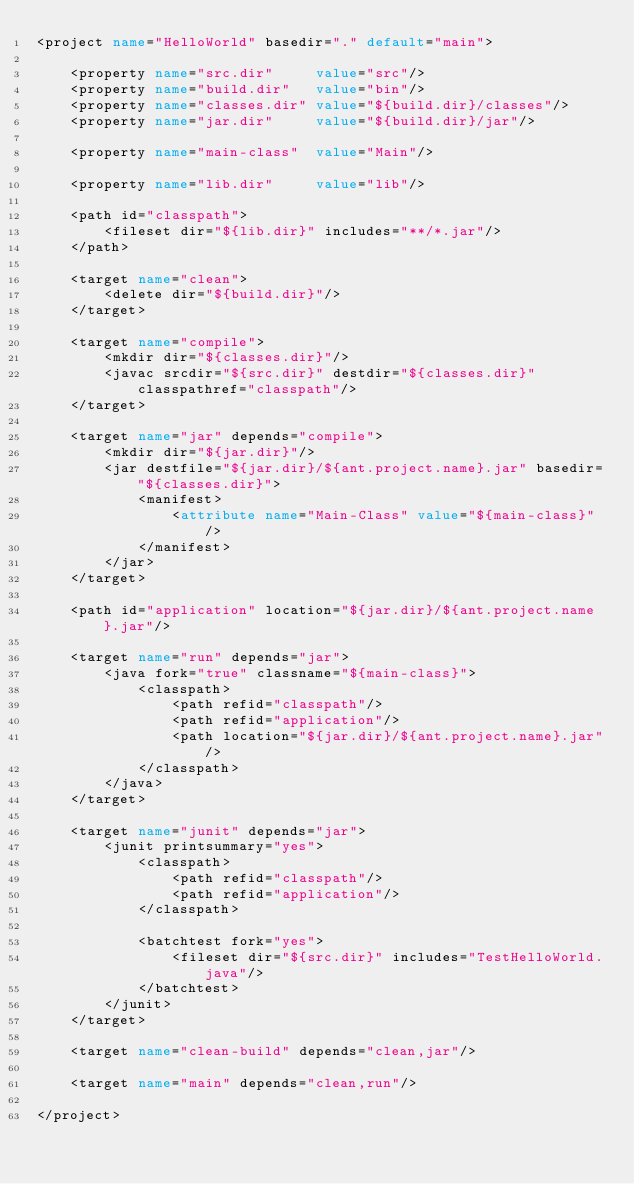Convert code to text. <code><loc_0><loc_0><loc_500><loc_500><_XML_><project name="HelloWorld" basedir="." default="main">

    <property name="src.dir"     value="src"/>
    <property name="build.dir"   value="bin"/>
    <property name="classes.dir" value="${build.dir}/classes"/>
    <property name="jar.dir"     value="${build.dir}/jar"/>

    <property name="main-class"  value="Main"/>

    <property name="lib.dir"     value="lib"/>

    <path id="classpath">
        <fileset dir="${lib.dir}" includes="**/*.jar"/>
    </path>

    <target name="clean">
        <delete dir="${build.dir}"/>
    </target>

    <target name="compile">
        <mkdir dir="${classes.dir}"/>
        <javac srcdir="${src.dir}" destdir="${classes.dir}"  classpathref="classpath"/>
    </target>

    <target name="jar" depends="compile">
        <mkdir dir="${jar.dir}"/>
        <jar destfile="${jar.dir}/${ant.project.name}.jar" basedir="${classes.dir}">
            <manifest>
                <attribute name="Main-Class" value="${main-class}"/>
            </manifest>
        </jar>
    </target>

    <path id="application" location="${jar.dir}/${ant.project.name}.jar"/>

    <target name="run" depends="jar">
        <java fork="true" classname="${main-class}">
            <classpath>
                <path refid="classpath"/>
                <path refid="application"/>
                <path location="${jar.dir}/${ant.project.name}.jar"/>
            </classpath>
        </java>
    </target>

    <target name="junit" depends="jar">
        <junit printsummary="yes">
            <classpath>
                <path refid="classpath"/>
                <path refid="application"/>
            </classpath>

            <batchtest fork="yes">
                <fileset dir="${src.dir}" includes="TestHelloWorld.java"/>
            </batchtest>
        </junit>
    </target>

    <target name="clean-build" depends="clean,jar"/>

    <target name="main" depends="clean,run"/>

</project>
</code> 